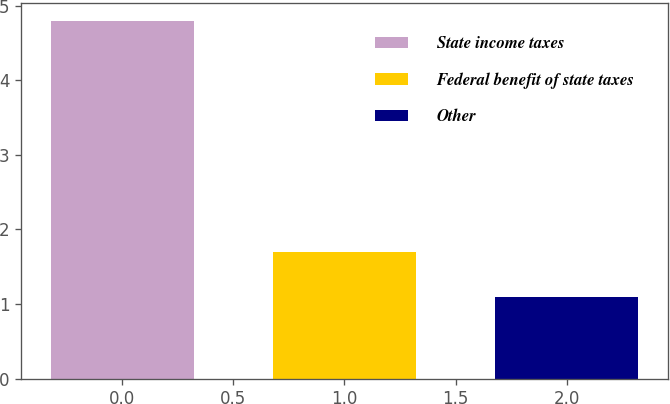Convert chart to OTSL. <chart><loc_0><loc_0><loc_500><loc_500><bar_chart><fcel>State income taxes<fcel>Federal benefit of state taxes<fcel>Other<nl><fcel>4.8<fcel>1.7<fcel>1.1<nl></chart> 